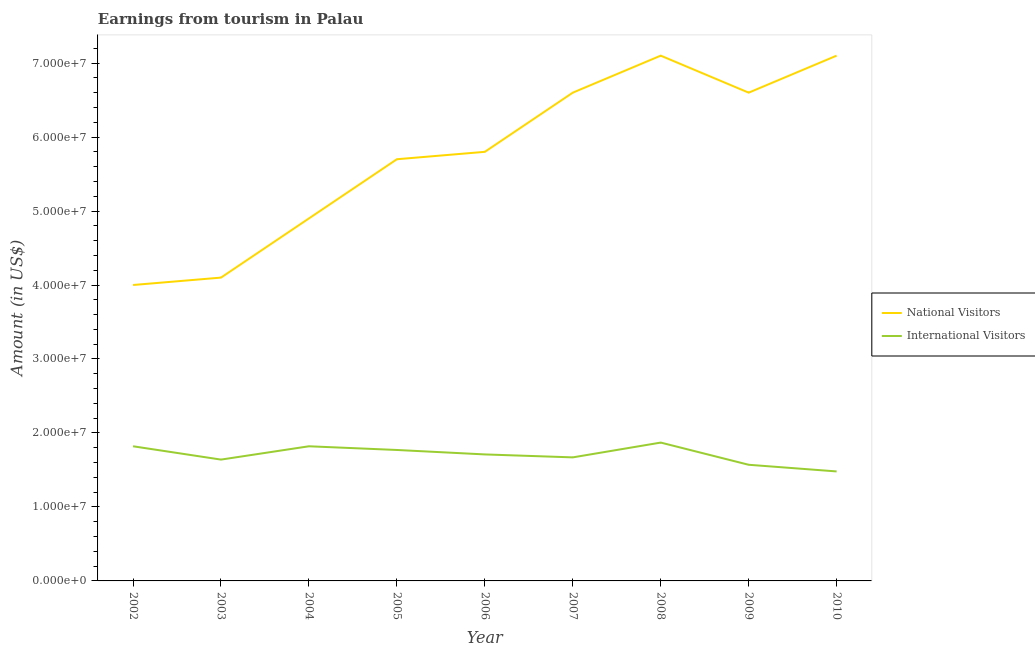Does the line corresponding to amount earned from national visitors intersect with the line corresponding to amount earned from international visitors?
Offer a very short reply. No. Is the number of lines equal to the number of legend labels?
Provide a short and direct response. Yes. What is the amount earned from international visitors in 2009?
Provide a succinct answer. 1.57e+07. Across all years, what is the maximum amount earned from international visitors?
Your response must be concise. 1.87e+07. Across all years, what is the minimum amount earned from international visitors?
Provide a short and direct response. 1.48e+07. In which year was the amount earned from international visitors maximum?
Your answer should be compact. 2008. In which year was the amount earned from national visitors minimum?
Offer a terse response. 2002. What is the total amount earned from international visitors in the graph?
Ensure brevity in your answer.  1.54e+08. What is the difference between the amount earned from international visitors in 2008 and that in 2009?
Your answer should be compact. 3.00e+06. What is the difference between the amount earned from international visitors in 2010 and the amount earned from national visitors in 2005?
Ensure brevity in your answer.  -4.22e+07. What is the average amount earned from international visitors per year?
Keep it short and to the point. 1.71e+07. In the year 2007, what is the difference between the amount earned from international visitors and amount earned from national visitors?
Give a very brief answer. -4.93e+07. What is the ratio of the amount earned from national visitors in 2006 to that in 2008?
Your answer should be very brief. 0.82. Is the amount earned from national visitors in 2002 less than that in 2003?
Ensure brevity in your answer.  Yes. Is the difference between the amount earned from international visitors in 2003 and 2008 greater than the difference between the amount earned from national visitors in 2003 and 2008?
Provide a succinct answer. Yes. What is the difference between the highest and the second highest amount earned from international visitors?
Your answer should be very brief. 5.00e+05. What is the difference between the highest and the lowest amount earned from national visitors?
Ensure brevity in your answer.  3.10e+07. In how many years, is the amount earned from national visitors greater than the average amount earned from national visitors taken over all years?
Your answer should be very brief. 5. Does the amount earned from international visitors monotonically increase over the years?
Provide a succinct answer. No. Is the amount earned from national visitors strictly greater than the amount earned from international visitors over the years?
Keep it short and to the point. Yes. How many years are there in the graph?
Offer a terse response. 9. What is the difference between two consecutive major ticks on the Y-axis?
Offer a terse response. 1.00e+07. Does the graph contain any zero values?
Your answer should be very brief. No. What is the title of the graph?
Offer a terse response. Earnings from tourism in Palau. What is the label or title of the Y-axis?
Keep it short and to the point. Amount (in US$). What is the Amount (in US$) of National Visitors in 2002?
Give a very brief answer. 4.00e+07. What is the Amount (in US$) of International Visitors in 2002?
Provide a short and direct response. 1.82e+07. What is the Amount (in US$) in National Visitors in 2003?
Ensure brevity in your answer.  4.10e+07. What is the Amount (in US$) in International Visitors in 2003?
Give a very brief answer. 1.64e+07. What is the Amount (in US$) of National Visitors in 2004?
Provide a short and direct response. 4.90e+07. What is the Amount (in US$) in International Visitors in 2004?
Give a very brief answer. 1.82e+07. What is the Amount (in US$) in National Visitors in 2005?
Provide a succinct answer. 5.70e+07. What is the Amount (in US$) in International Visitors in 2005?
Make the answer very short. 1.77e+07. What is the Amount (in US$) in National Visitors in 2006?
Give a very brief answer. 5.80e+07. What is the Amount (in US$) of International Visitors in 2006?
Your answer should be very brief. 1.71e+07. What is the Amount (in US$) of National Visitors in 2007?
Your response must be concise. 6.60e+07. What is the Amount (in US$) in International Visitors in 2007?
Ensure brevity in your answer.  1.67e+07. What is the Amount (in US$) in National Visitors in 2008?
Make the answer very short. 7.10e+07. What is the Amount (in US$) of International Visitors in 2008?
Offer a terse response. 1.87e+07. What is the Amount (in US$) of National Visitors in 2009?
Give a very brief answer. 6.60e+07. What is the Amount (in US$) of International Visitors in 2009?
Make the answer very short. 1.57e+07. What is the Amount (in US$) of National Visitors in 2010?
Offer a very short reply. 7.10e+07. What is the Amount (in US$) in International Visitors in 2010?
Ensure brevity in your answer.  1.48e+07. Across all years, what is the maximum Amount (in US$) of National Visitors?
Offer a very short reply. 7.10e+07. Across all years, what is the maximum Amount (in US$) of International Visitors?
Your answer should be compact. 1.87e+07. Across all years, what is the minimum Amount (in US$) in National Visitors?
Provide a succinct answer. 4.00e+07. Across all years, what is the minimum Amount (in US$) in International Visitors?
Your answer should be compact. 1.48e+07. What is the total Amount (in US$) in National Visitors in the graph?
Provide a succinct answer. 5.19e+08. What is the total Amount (in US$) of International Visitors in the graph?
Keep it short and to the point. 1.54e+08. What is the difference between the Amount (in US$) of National Visitors in 2002 and that in 2003?
Offer a terse response. -1.00e+06. What is the difference between the Amount (in US$) in International Visitors in 2002 and that in 2003?
Offer a very short reply. 1.80e+06. What is the difference between the Amount (in US$) of National Visitors in 2002 and that in 2004?
Offer a very short reply. -9.00e+06. What is the difference between the Amount (in US$) of National Visitors in 2002 and that in 2005?
Ensure brevity in your answer.  -1.70e+07. What is the difference between the Amount (in US$) of International Visitors in 2002 and that in 2005?
Make the answer very short. 5.00e+05. What is the difference between the Amount (in US$) in National Visitors in 2002 and that in 2006?
Give a very brief answer. -1.80e+07. What is the difference between the Amount (in US$) in International Visitors in 2002 and that in 2006?
Provide a succinct answer. 1.10e+06. What is the difference between the Amount (in US$) of National Visitors in 2002 and that in 2007?
Offer a very short reply. -2.60e+07. What is the difference between the Amount (in US$) in International Visitors in 2002 and that in 2007?
Offer a very short reply. 1.50e+06. What is the difference between the Amount (in US$) in National Visitors in 2002 and that in 2008?
Offer a very short reply. -3.10e+07. What is the difference between the Amount (in US$) in International Visitors in 2002 and that in 2008?
Offer a terse response. -5.00e+05. What is the difference between the Amount (in US$) in National Visitors in 2002 and that in 2009?
Ensure brevity in your answer.  -2.60e+07. What is the difference between the Amount (in US$) of International Visitors in 2002 and that in 2009?
Offer a very short reply. 2.50e+06. What is the difference between the Amount (in US$) in National Visitors in 2002 and that in 2010?
Give a very brief answer. -3.10e+07. What is the difference between the Amount (in US$) of International Visitors in 2002 and that in 2010?
Your answer should be compact. 3.40e+06. What is the difference between the Amount (in US$) in National Visitors in 2003 and that in 2004?
Your answer should be very brief. -8.00e+06. What is the difference between the Amount (in US$) in International Visitors in 2003 and that in 2004?
Provide a succinct answer. -1.80e+06. What is the difference between the Amount (in US$) of National Visitors in 2003 and that in 2005?
Provide a succinct answer. -1.60e+07. What is the difference between the Amount (in US$) of International Visitors in 2003 and that in 2005?
Your response must be concise. -1.30e+06. What is the difference between the Amount (in US$) of National Visitors in 2003 and that in 2006?
Your answer should be compact. -1.70e+07. What is the difference between the Amount (in US$) in International Visitors in 2003 and that in 2006?
Offer a very short reply. -7.00e+05. What is the difference between the Amount (in US$) in National Visitors in 2003 and that in 2007?
Give a very brief answer. -2.50e+07. What is the difference between the Amount (in US$) in National Visitors in 2003 and that in 2008?
Make the answer very short. -3.00e+07. What is the difference between the Amount (in US$) of International Visitors in 2003 and that in 2008?
Your answer should be compact. -2.30e+06. What is the difference between the Amount (in US$) of National Visitors in 2003 and that in 2009?
Make the answer very short. -2.50e+07. What is the difference between the Amount (in US$) in International Visitors in 2003 and that in 2009?
Make the answer very short. 7.00e+05. What is the difference between the Amount (in US$) in National Visitors in 2003 and that in 2010?
Provide a succinct answer. -3.00e+07. What is the difference between the Amount (in US$) in International Visitors in 2003 and that in 2010?
Provide a short and direct response. 1.60e+06. What is the difference between the Amount (in US$) in National Visitors in 2004 and that in 2005?
Provide a succinct answer. -8.00e+06. What is the difference between the Amount (in US$) in National Visitors in 2004 and that in 2006?
Offer a terse response. -9.00e+06. What is the difference between the Amount (in US$) in International Visitors in 2004 and that in 2006?
Your response must be concise. 1.10e+06. What is the difference between the Amount (in US$) of National Visitors in 2004 and that in 2007?
Keep it short and to the point. -1.70e+07. What is the difference between the Amount (in US$) in International Visitors in 2004 and that in 2007?
Offer a very short reply. 1.50e+06. What is the difference between the Amount (in US$) in National Visitors in 2004 and that in 2008?
Make the answer very short. -2.20e+07. What is the difference between the Amount (in US$) of International Visitors in 2004 and that in 2008?
Offer a very short reply. -5.00e+05. What is the difference between the Amount (in US$) in National Visitors in 2004 and that in 2009?
Your response must be concise. -1.70e+07. What is the difference between the Amount (in US$) of International Visitors in 2004 and that in 2009?
Keep it short and to the point. 2.50e+06. What is the difference between the Amount (in US$) in National Visitors in 2004 and that in 2010?
Offer a very short reply. -2.20e+07. What is the difference between the Amount (in US$) in International Visitors in 2004 and that in 2010?
Provide a succinct answer. 3.40e+06. What is the difference between the Amount (in US$) in National Visitors in 2005 and that in 2006?
Offer a terse response. -1.00e+06. What is the difference between the Amount (in US$) of International Visitors in 2005 and that in 2006?
Offer a terse response. 6.00e+05. What is the difference between the Amount (in US$) in National Visitors in 2005 and that in 2007?
Keep it short and to the point. -9.00e+06. What is the difference between the Amount (in US$) of International Visitors in 2005 and that in 2007?
Give a very brief answer. 1.00e+06. What is the difference between the Amount (in US$) of National Visitors in 2005 and that in 2008?
Offer a terse response. -1.40e+07. What is the difference between the Amount (in US$) of International Visitors in 2005 and that in 2008?
Your answer should be compact. -1.00e+06. What is the difference between the Amount (in US$) of National Visitors in 2005 and that in 2009?
Give a very brief answer. -9.00e+06. What is the difference between the Amount (in US$) of National Visitors in 2005 and that in 2010?
Your response must be concise. -1.40e+07. What is the difference between the Amount (in US$) in International Visitors in 2005 and that in 2010?
Your answer should be compact. 2.90e+06. What is the difference between the Amount (in US$) of National Visitors in 2006 and that in 2007?
Ensure brevity in your answer.  -8.00e+06. What is the difference between the Amount (in US$) in National Visitors in 2006 and that in 2008?
Provide a succinct answer. -1.30e+07. What is the difference between the Amount (in US$) of International Visitors in 2006 and that in 2008?
Make the answer very short. -1.60e+06. What is the difference between the Amount (in US$) of National Visitors in 2006 and that in 2009?
Provide a short and direct response. -8.00e+06. What is the difference between the Amount (in US$) of International Visitors in 2006 and that in 2009?
Offer a terse response. 1.40e+06. What is the difference between the Amount (in US$) in National Visitors in 2006 and that in 2010?
Make the answer very short. -1.30e+07. What is the difference between the Amount (in US$) of International Visitors in 2006 and that in 2010?
Ensure brevity in your answer.  2.30e+06. What is the difference between the Amount (in US$) of National Visitors in 2007 and that in 2008?
Make the answer very short. -5.00e+06. What is the difference between the Amount (in US$) in National Visitors in 2007 and that in 2009?
Ensure brevity in your answer.  0. What is the difference between the Amount (in US$) in National Visitors in 2007 and that in 2010?
Ensure brevity in your answer.  -5.00e+06. What is the difference between the Amount (in US$) in International Visitors in 2007 and that in 2010?
Give a very brief answer. 1.90e+06. What is the difference between the Amount (in US$) of International Visitors in 2008 and that in 2010?
Give a very brief answer. 3.90e+06. What is the difference between the Amount (in US$) of National Visitors in 2009 and that in 2010?
Ensure brevity in your answer.  -5.00e+06. What is the difference between the Amount (in US$) of National Visitors in 2002 and the Amount (in US$) of International Visitors in 2003?
Offer a very short reply. 2.36e+07. What is the difference between the Amount (in US$) of National Visitors in 2002 and the Amount (in US$) of International Visitors in 2004?
Provide a succinct answer. 2.18e+07. What is the difference between the Amount (in US$) in National Visitors in 2002 and the Amount (in US$) in International Visitors in 2005?
Offer a terse response. 2.23e+07. What is the difference between the Amount (in US$) of National Visitors in 2002 and the Amount (in US$) of International Visitors in 2006?
Give a very brief answer. 2.29e+07. What is the difference between the Amount (in US$) in National Visitors in 2002 and the Amount (in US$) in International Visitors in 2007?
Provide a short and direct response. 2.33e+07. What is the difference between the Amount (in US$) in National Visitors in 2002 and the Amount (in US$) in International Visitors in 2008?
Your answer should be compact. 2.13e+07. What is the difference between the Amount (in US$) in National Visitors in 2002 and the Amount (in US$) in International Visitors in 2009?
Ensure brevity in your answer.  2.43e+07. What is the difference between the Amount (in US$) of National Visitors in 2002 and the Amount (in US$) of International Visitors in 2010?
Offer a very short reply. 2.52e+07. What is the difference between the Amount (in US$) of National Visitors in 2003 and the Amount (in US$) of International Visitors in 2004?
Your answer should be very brief. 2.28e+07. What is the difference between the Amount (in US$) of National Visitors in 2003 and the Amount (in US$) of International Visitors in 2005?
Your response must be concise. 2.33e+07. What is the difference between the Amount (in US$) in National Visitors in 2003 and the Amount (in US$) in International Visitors in 2006?
Give a very brief answer. 2.39e+07. What is the difference between the Amount (in US$) in National Visitors in 2003 and the Amount (in US$) in International Visitors in 2007?
Provide a short and direct response. 2.43e+07. What is the difference between the Amount (in US$) in National Visitors in 2003 and the Amount (in US$) in International Visitors in 2008?
Provide a succinct answer. 2.23e+07. What is the difference between the Amount (in US$) in National Visitors in 2003 and the Amount (in US$) in International Visitors in 2009?
Offer a very short reply. 2.53e+07. What is the difference between the Amount (in US$) in National Visitors in 2003 and the Amount (in US$) in International Visitors in 2010?
Provide a succinct answer. 2.62e+07. What is the difference between the Amount (in US$) in National Visitors in 2004 and the Amount (in US$) in International Visitors in 2005?
Make the answer very short. 3.13e+07. What is the difference between the Amount (in US$) of National Visitors in 2004 and the Amount (in US$) of International Visitors in 2006?
Your answer should be very brief. 3.19e+07. What is the difference between the Amount (in US$) of National Visitors in 2004 and the Amount (in US$) of International Visitors in 2007?
Keep it short and to the point. 3.23e+07. What is the difference between the Amount (in US$) of National Visitors in 2004 and the Amount (in US$) of International Visitors in 2008?
Give a very brief answer. 3.03e+07. What is the difference between the Amount (in US$) in National Visitors in 2004 and the Amount (in US$) in International Visitors in 2009?
Make the answer very short. 3.33e+07. What is the difference between the Amount (in US$) in National Visitors in 2004 and the Amount (in US$) in International Visitors in 2010?
Offer a terse response. 3.42e+07. What is the difference between the Amount (in US$) in National Visitors in 2005 and the Amount (in US$) in International Visitors in 2006?
Provide a short and direct response. 3.99e+07. What is the difference between the Amount (in US$) in National Visitors in 2005 and the Amount (in US$) in International Visitors in 2007?
Keep it short and to the point. 4.03e+07. What is the difference between the Amount (in US$) of National Visitors in 2005 and the Amount (in US$) of International Visitors in 2008?
Provide a succinct answer. 3.83e+07. What is the difference between the Amount (in US$) in National Visitors in 2005 and the Amount (in US$) in International Visitors in 2009?
Offer a very short reply. 4.13e+07. What is the difference between the Amount (in US$) of National Visitors in 2005 and the Amount (in US$) of International Visitors in 2010?
Keep it short and to the point. 4.22e+07. What is the difference between the Amount (in US$) in National Visitors in 2006 and the Amount (in US$) in International Visitors in 2007?
Give a very brief answer. 4.13e+07. What is the difference between the Amount (in US$) in National Visitors in 2006 and the Amount (in US$) in International Visitors in 2008?
Your answer should be compact. 3.93e+07. What is the difference between the Amount (in US$) of National Visitors in 2006 and the Amount (in US$) of International Visitors in 2009?
Provide a succinct answer. 4.23e+07. What is the difference between the Amount (in US$) in National Visitors in 2006 and the Amount (in US$) in International Visitors in 2010?
Offer a very short reply. 4.32e+07. What is the difference between the Amount (in US$) of National Visitors in 2007 and the Amount (in US$) of International Visitors in 2008?
Make the answer very short. 4.73e+07. What is the difference between the Amount (in US$) in National Visitors in 2007 and the Amount (in US$) in International Visitors in 2009?
Your answer should be very brief. 5.03e+07. What is the difference between the Amount (in US$) in National Visitors in 2007 and the Amount (in US$) in International Visitors in 2010?
Your response must be concise. 5.12e+07. What is the difference between the Amount (in US$) of National Visitors in 2008 and the Amount (in US$) of International Visitors in 2009?
Your response must be concise. 5.53e+07. What is the difference between the Amount (in US$) of National Visitors in 2008 and the Amount (in US$) of International Visitors in 2010?
Your response must be concise. 5.62e+07. What is the difference between the Amount (in US$) of National Visitors in 2009 and the Amount (in US$) of International Visitors in 2010?
Your answer should be compact. 5.12e+07. What is the average Amount (in US$) in National Visitors per year?
Keep it short and to the point. 5.77e+07. What is the average Amount (in US$) in International Visitors per year?
Ensure brevity in your answer.  1.71e+07. In the year 2002, what is the difference between the Amount (in US$) in National Visitors and Amount (in US$) in International Visitors?
Offer a terse response. 2.18e+07. In the year 2003, what is the difference between the Amount (in US$) of National Visitors and Amount (in US$) of International Visitors?
Keep it short and to the point. 2.46e+07. In the year 2004, what is the difference between the Amount (in US$) in National Visitors and Amount (in US$) in International Visitors?
Your answer should be compact. 3.08e+07. In the year 2005, what is the difference between the Amount (in US$) of National Visitors and Amount (in US$) of International Visitors?
Provide a succinct answer. 3.93e+07. In the year 2006, what is the difference between the Amount (in US$) in National Visitors and Amount (in US$) in International Visitors?
Your answer should be compact. 4.09e+07. In the year 2007, what is the difference between the Amount (in US$) in National Visitors and Amount (in US$) in International Visitors?
Give a very brief answer. 4.93e+07. In the year 2008, what is the difference between the Amount (in US$) of National Visitors and Amount (in US$) of International Visitors?
Your response must be concise. 5.23e+07. In the year 2009, what is the difference between the Amount (in US$) in National Visitors and Amount (in US$) in International Visitors?
Offer a terse response. 5.03e+07. In the year 2010, what is the difference between the Amount (in US$) in National Visitors and Amount (in US$) in International Visitors?
Provide a short and direct response. 5.62e+07. What is the ratio of the Amount (in US$) in National Visitors in 2002 to that in 2003?
Keep it short and to the point. 0.98. What is the ratio of the Amount (in US$) of International Visitors in 2002 to that in 2003?
Give a very brief answer. 1.11. What is the ratio of the Amount (in US$) in National Visitors in 2002 to that in 2004?
Provide a short and direct response. 0.82. What is the ratio of the Amount (in US$) of International Visitors in 2002 to that in 2004?
Ensure brevity in your answer.  1. What is the ratio of the Amount (in US$) of National Visitors in 2002 to that in 2005?
Offer a very short reply. 0.7. What is the ratio of the Amount (in US$) of International Visitors in 2002 to that in 2005?
Provide a short and direct response. 1.03. What is the ratio of the Amount (in US$) in National Visitors in 2002 to that in 2006?
Your response must be concise. 0.69. What is the ratio of the Amount (in US$) in International Visitors in 2002 to that in 2006?
Make the answer very short. 1.06. What is the ratio of the Amount (in US$) of National Visitors in 2002 to that in 2007?
Make the answer very short. 0.61. What is the ratio of the Amount (in US$) of International Visitors in 2002 to that in 2007?
Provide a short and direct response. 1.09. What is the ratio of the Amount (in US$) in National Visitors in 2002 to that in 2008?
Offer a terse response. 0.56. What is the ratio of the Amount (in US$) of International Visitors in 2002 to that in 2008?
Give a very brief answer. 0.97. What is the ratio of the Amount (in US$) of National Visitors in 2002 to that in 2009?
Make the answer very short. 0.61. What is the ratio of the Amount (in US$) in International Visitors in 2002 to that in 2009?
Your answer should be compact. 1.16. What is the ratio of the Amount (in US$) in National Visitors in 2002 to that in 2010?
Your answer should be compact. 0.56. What is the ratio of the Amount (in US$) in International Visitors in 2002 to that in 2010?
Make the answer very short. 1.23. What is the ratio of the Amount (in US$) of National Visitors in 2003 to that in 2004?
Provide a succinct answer. 0.84. What is the ratio of the Amount (in US$) in International Visitors in 2003 to that in 2004?
Your answer should be compact. 0.9. What is the ratio of the Amount (in US$) in National Visitors in 2003 to that in 2005?
Keep it short and to the point. 0.72. What is the ratio of the Amount (in US$) of International Visitors in 2003 to that in 2005?
Provide a short and direct response. 0.93. What is the ratio of the Amount (in US$) of National Visitors in 2003 to that in 2006?
Offer a terse response. 0.71. What is the ratio of the Amount (in US$) of International Visitors in 2003 to that in 2006?
Offer a very short reply. 0.96. What is the ratio of the Amount (in US$) of National Visitors in 2003 to that in 2007?
Ensure brevity in your answer.  0.62. What is the ratio of the Amount (in US$) in International Visitors in 2003 to that in 2007?
Ensure brevity in your answer.  0.98. What is the ratio of the Amount (in US$) of National Visitors in 2003 to that in 2008?
Provide a short and direct response. 0.58. What is the ratio of the Amount (in US$) in International Visitors in 2003 to that in 2008?
Offer a terse response. 0.88. What is the ratio of the Amount (in US$) of National Visitors in 2003 to that in 2009?
Offer a terse response. 0.62. What is the ratio of the Amount (in US$) of International Visitors in 2003 to that in 2009?
Keep it short and to the point. 1.04. What is the ratio of the Amount (in US$) of National Visitors in 2003 to that in 2010?
Ensure brevity in your answer.  0.58. What is the ratio of the Amount (in US$) of International Visitors in 2003 to that in 2010?
Offer a terse response. 1.11. What is the ratio of the Amount (in US$) in National Visitors in 2004 to that in 2005?
Your answer should be compact. 0.86. What is the ratio of the Amount (in US$) of International Visitors in 2004 to that in 2005?
Give a very brief answer. 1.03. What is the ratio of the Amount (in US$) in National Visitors in 2004 to that in 2006?
Offer a very short reply. 0.84. What is the ratio of the Amount (in US$) in International Visitors in 2004 to that in 2006?
Give a very brief answer. 1.06. What is the ratio of the Amount (in US$) in National Visitors in 2004 to that in 2007?
Ensure brevity in your answer.  0.74. What is the ratio of the Amount (in US$) in International Visitors in 2004 to that in 2007?
Your answer should be very brief. 1.09. What is the ratio of the Amount (in US$) in National Visitors in 2004 to that in 2008?
Provide a succinct answer. 0.69. What is the ratio of the Amount (in US$) of International Visitors in 2004 to that in 2008?
Give a very brief answer. 0.97. What is the ratio of the Amount (in US$) in National Visitors in 2004 to that in 2009?
Ensure brevity in your answer.  0.74. What is the ratio of the Amount (in US$) in International Visitors in 2004 to that in 2009?
Your answer should be compact. 1.16. What is the ratio of the Amount (in US$) of National Visitors in 2004 to that in 2010?
Make the answer very short. 0.69. What is the ratio of the Amount (in US$) in International Visitors in 2004 to that in 2010?
Your response must be concise. 1.23. What is the ratio of the Amount (in US$) in National Visitors in 2005 to that in 2006?
Ensure brevity in your answer.  0.98. What is the ratio of the Amount (in US$) in International Visitors in 2005 to that in 2006?
Offer a very short reply. 1.04. What is the ratio of the Amount (in US$) in National Visitors in 2005 to that in 2007?
Keep it short and to the point. 0.86. What is the ratio of the Amount (in US$) of International Visitors in 2005 to that in 2007?
Offer a terse response. 1.06. What is the ratio of the Amount (in US$) of National Visitors in 2005 to that in 2008?
Make the answer very short. 0.8. What is the ratio of the Amount (in US$) of International Visitors in 2005 to that in 2008?
Ensure brevity in your answer.  0.95. What is the ratio of the Amount (in US$) of National Visitors in 2005 to that in 2009?
Offer a very short reply. 0.86. What is the ratio of the Amount (in US$) of International Visitors in 2005 to that in 2009?
Provide a short and direct response. 1.13. What is the ratio of the Amount (in US$) in National Visitors in 2005 to that in 2010?
Give a very brief answer. 0.8. What is the ratio of the Amount (in US$) in International Visitors in 2005 to that in 2010?
Offer a terse response. 1.2. What is the ratio of the Amount (in US$) of National Visitors in 2006 to that in 2007?
Offer a very short reply. 0.88. What is the ratio of the Amount (in US$) of International Visitors in 2006 to that in 2007?
Offer a very short reply. 1.02. What is the ratio of the Amount (in US$) in National Visitors in 2006 to that in 2008?
Provide a succinct answer. 0.82. What is the ratio of the Amount (in US$) of International Visitors in 2006 to that in 2008?
Offer a terse response. 0.91. What is the ratio of the Amount (in US$) in National Visitors in 2006 to that in 2009?
Your answer should be very brief. 0.88. What is the ratio of the Amount (in US$) in International Visitors in 2006 to that in 2009?
Your response must be concise. 1.09. What is the ratio of the Amount (in US$) of National Visitors in 2006 to that in 2010?
Your answer should be compact. 0.82. What is the ratio of the Amount (in US$) of International Visitors in 2006 to that in 2010?
Provide a succinct answer. 1.16. What is the ratio of the Amount (in US$) in National Visitors in 2007 to that in 2008?
Make the answer very short. 0.93. What is the ratio of the Amount (in US$) of International Visitors in 2007 to that in 2008?
Your answer should be compact. 0.89. What is the ratio of the Amount (in US$) of International Visitors in 2007 to that in 2009?
Offer a very short reply. 1.06. What is the ratio of the Amount (in US$) in National Visitors in 2007 to that in 2010?
Offer a very short reply. 0.93. What is the ratio of the Amount (in US$) in International Visitors in 2007 to that in 2010?
Make the answer very short. 1.13. What is the ratio of the Amount (in US$) of National Visitors in 2008 to that in 2009?
Your answer should be very brief. 1.08. What is the ratio of the Amount (in US$) of International Visitors in 2008 to that in 2009?
Your response must be concise. 1.19. What is the ratio of the Amount (in US$) of National Visitors in 2008 to that in 2010?
Your answer should be very brief. 1. What is the ratio of the Amount (in US$) of International Visitors in 2008 to that in 2010?
Keep it short and to the point. 1.26. What is the ratio of the Amount (in US$) in National Visitors in 2009 to that in 2010?
Ensure brevity in your answer.  0.93. What is the ratio of the Amount (in US$) of International Visitors in 2009 to that in 2010?
Your response must be concise. 1.06. What is the difference between the highest and the lowest Amount (in US$) of National Visitors?
Keep it short and to the point. 3.10e+07. What is the difference between the highest and the lowest Amount (in US$) of International Visitors?
Your answer should be compact. 3.90e+06. 